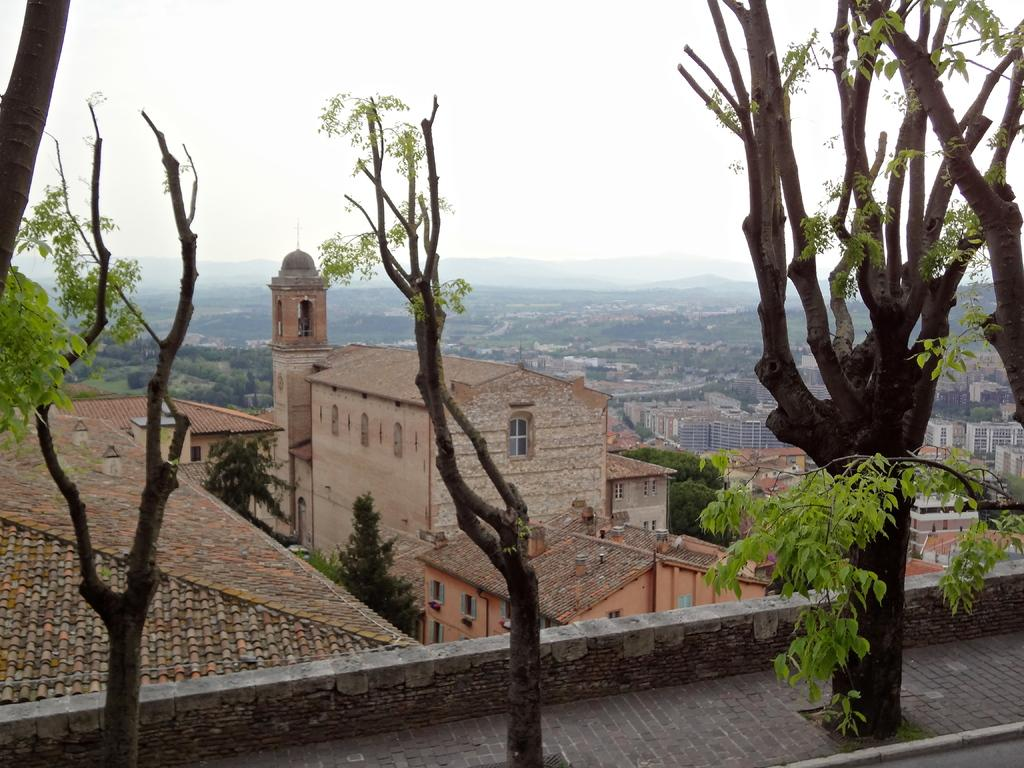What type of natural elements can be seen in the image? There are trees in the image. What architectural features are present in the image? There are windows and buildings in the image. What geographical features can be seen in the image? There are mountains in the image. What part of the natural environment is visible in the background of the image? The sky is visible in the background of the image. What type of rod can be seen in the image? There is no rod present in the image. Can you tell me how many teeth are visible in the image? There are no teeth visible in the image. 